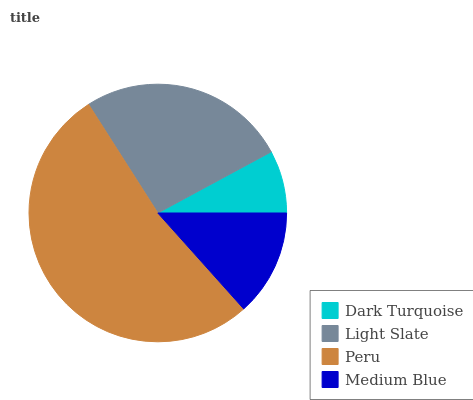Is Dark Turquoise the minimum?
Answer yes or no. Yes. Is Peru the maximum?
Answer yes or no. Yes. Is Light Slate the minimum?
Answer yes or no. No. Is Light Slate the maximum?
Answer yes or no. No. Is Light Slate greater than Dark Turquoise?
Answer yes or no. Yes. Is Dark Turquoise less than Light Slate?
Answer yes or no. Yes. Is Dark Turquoise greater than Light Slate?
Answer yes or no. No. Is Light Slate less than Dark Turquoise?
Answer yes or no. No. Is Light Slate the high median?
Answer yes or no. Yes. Is Medium Blue the low median?
Answer yes or no. Yes. Is Medium Blue the high median?
Answer yes or no. No. Is Peru the low median?
Answer yes or no. No. 